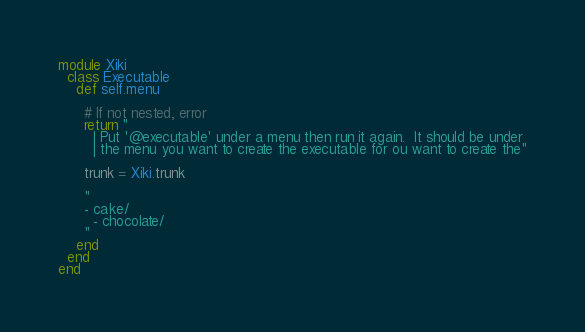<code> <loc_0><loc_0><loc_500><loc_500><_Ruby_>module Xiki
  class Executable
    def self.menu

      # If not nested, error
      return "
        | Put '@executable' under a menu then run it again.  It should be under
        | the menu you want to create the executable for ou want to create the"

      trunk = Xiki.trunk

      "
      - cake/
        - chocolate/
      "
    end
  end
end
</code> 